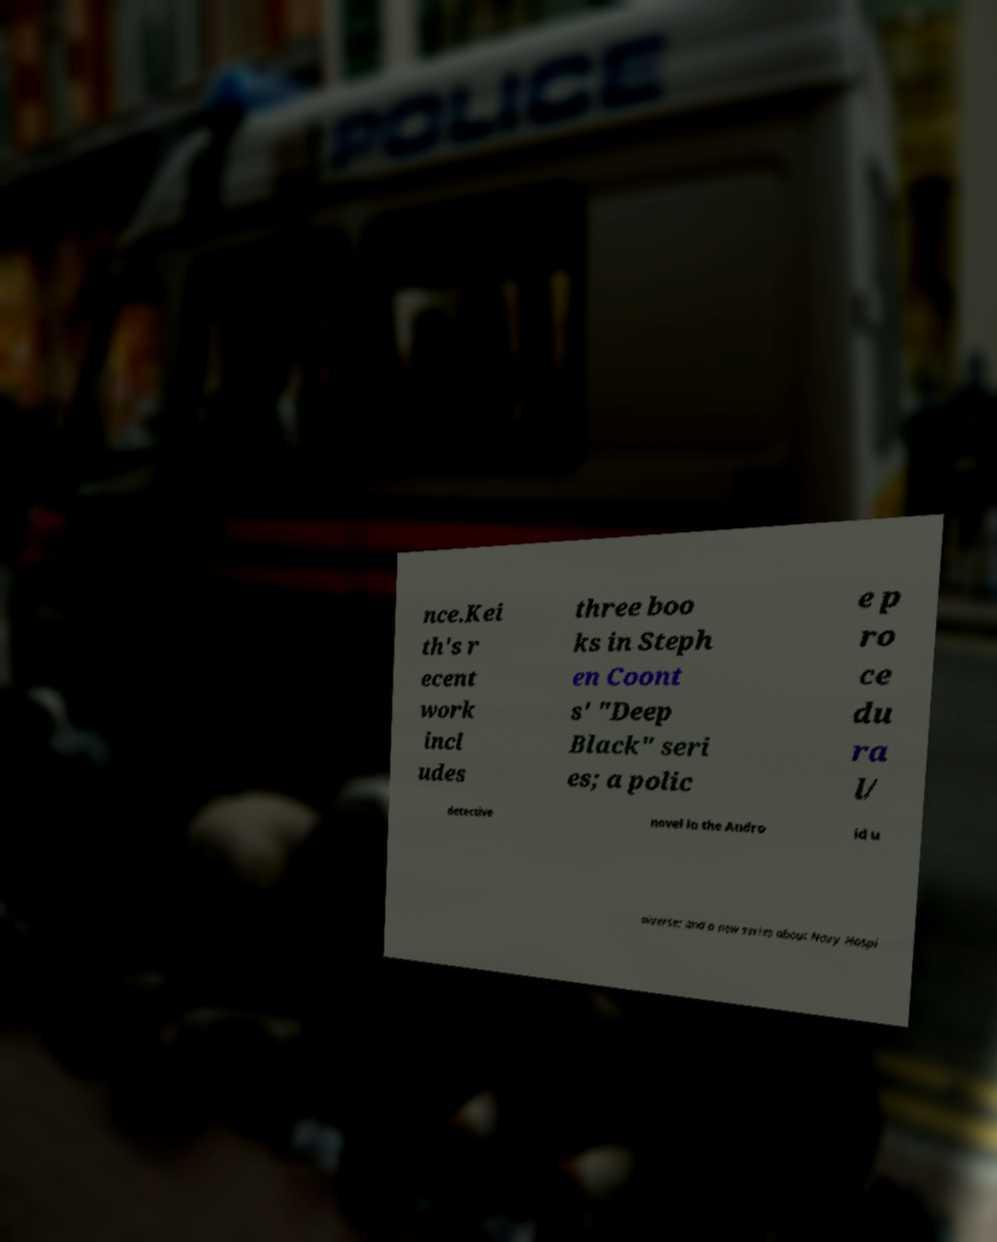Can you accurately transcribe the text from the provided image for me? nce.Kei th's r ecent work incl udes three boo ks in Steph en Coont s' "Deep Black" seri es; a polic e p ro ce du ra l/ detective novel in the Andro id u niverse; and a new series about Navy Hospi 